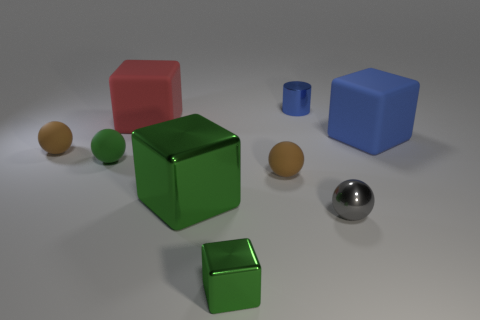Describe the arrangement of the colored cubes and how they differ in size. The cubes are arranged with no apparent pattern on a flat surface. There’s a large red and a large blue cube, and two green cubes, one of which is large and the other visibly smaller. The smaller green cube is located closer to the foreground. 